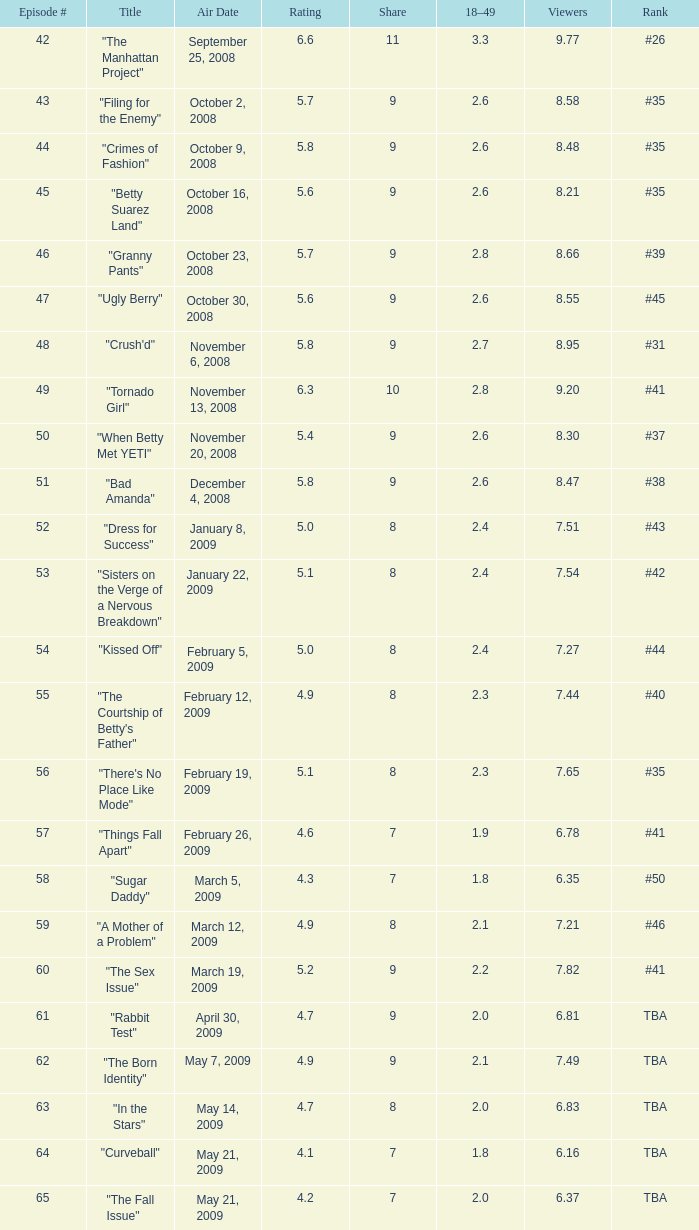What is the minimum number of viewers for an episode with a number greater than 58, titled "curveball" and a rating below None. 